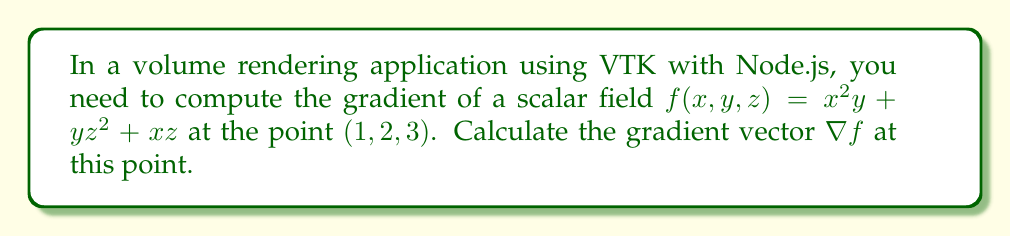Help me with this question. To compute the gradient of a scalar field, we need to find the partial derivatives with respect to each variable and evaluate them at the given point. The gradient is defined as:

$$\nabla f = \left(\frac{\partial f}{\partial x}, \frac{\partial f}{\partial y}, \frac{\partial f}{\partial z}\right)$$

Let's calculate each partial derivative:

1. $\frac{\partial f}{\partial x}$:
   $$\frac{\partial f}{\partial x} = 2xy + z$$

2. $\frac{\partial f}{\partial y}$:
   $$\frac{\partial f}{\partial y} = x^2 + z^2$$

3. $\frac{\partial f}{\partial z}$:
   $$\frac{\partial f}{\partial z} = 2yz + x$$

Now, we evaluate these partial derivatives at the point $(1,2,3)$:

1. $\frac{\partial f}{\partial x}(1,2,3) = 2(1)(2) + 3 = 7$

2. $\frac{\partial f}{\partial y}(1,2,3) = 1^2 + 3^2 = 10$

3. $\frac{\partial f}{\partial z}(1,2,3) = 2(2)(3) + 1 = 13$

Therefore, the gradient vector at $(1,2,3)$ is:

$$\nabla f(1,2,3) = (7, 10, 13)$$
Answer: $(7, 10, 13)$ 